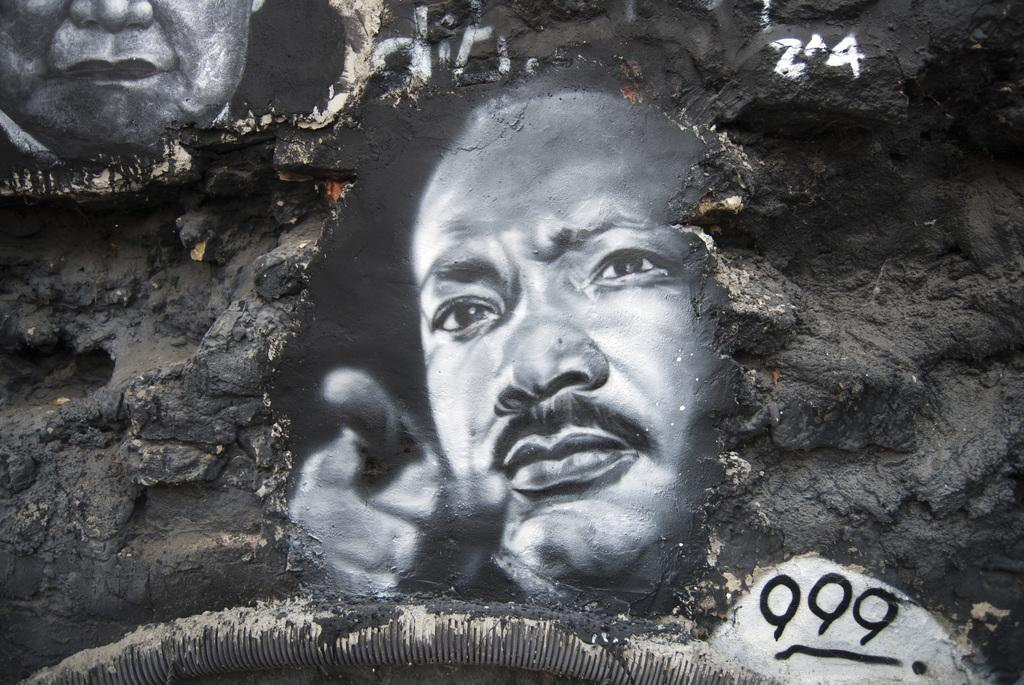What is depicted on the rock in the image? There is a painting of two people's faces on a rock. What else can be seen attached to the rock? There is a pipe attached to the rock. What date is circled on the calendar in the image? There is no calendar present in the image. What type of voice can be heard coming from the rock in the image? There is no voice present in the image. 